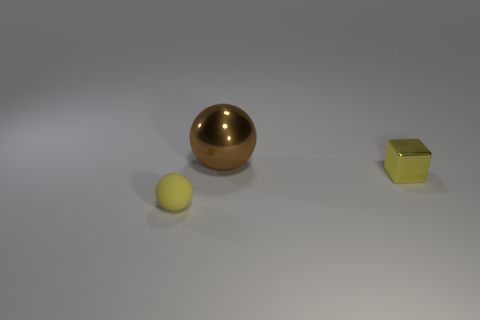What number of other objects are the same shape as the tiny metal thing?
Make the answer very short. 0. What color is the cube that is the same size as the yellow rubber thing?
Keep it short and to the point. Yellow. How many things are yellow metallic objects or brown metal blocks?
Your response must be concise. 1. Are there any big spheres behind the small block?
Offer a very short reply. Yes. Are there any yellow cubes made of the same material as the big thing?
Provide a succinct answer. Yes. The object that is the same color as the small ball is what size?
Ensure brevity in your answer.  Small. How many cylinders are tiny green things or small yellow things?
Keep it short and to the point. 0. Are there more objects that are behind the small yellow rubber ball than spheres that are left of the large shiny thing?
Provide a short and direct response. Yes. How many big metallic balls have the same color as the matte ball?
Offer a terse response. 0. There is a thing that is the same material as the small cube; what is its size?
Offer a very short reply. Large. 